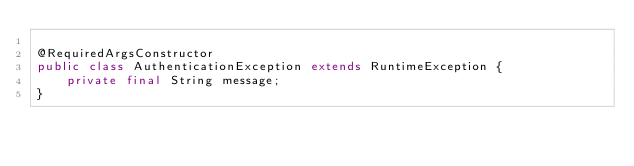Convert code to text. <code><loc_0><loc_0><loc_500><loc_500><_Java_>
@RequiredArgsConstructor
public class AuthenticationException extends RuntimeException {
    private final String message;
}
</code> 